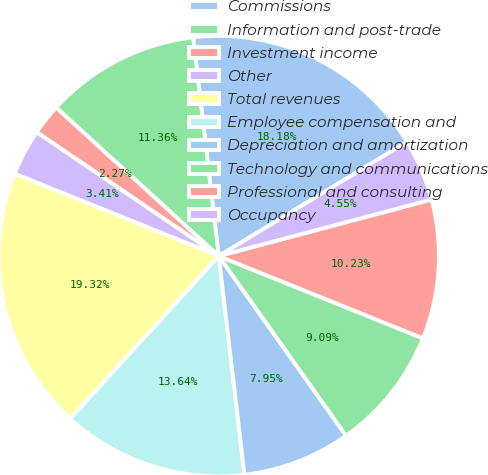<chart> <loc_0><loc_0><loc_500><loc_500><pie_chart><fcel>Commissions<fcel>Information and post-trade<fcel>Investment income<fcel>Other<fcel>Total revenues<fcel>Employee compensation and<fcel>Depreciation and amortization<fcel>Technology and communications<fcel>Professional and consulting<fcel>Occupancy<nl><fcel>18.18%<fcel>11.36%<fcel>2.27%<fcel>3.41%<fcel>19.32%<fcel>13.64%<fcel>7.95%<fcel>9.09%<fcel>10.23%<fcel>4.55%<nl></chart> 